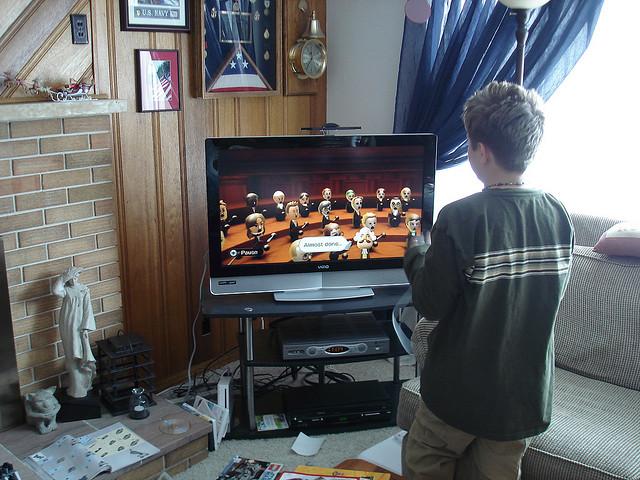Is this a cafe?
Short answer required. No. Is the boy playing with someone?
Give a very brief answer. No. Are there stripes on his shirt?
Write a very short answer. Yes. What does the screen say?
Answer briefly. Almost done. Is there a statue on the floor?
Concise answer only. Yes. How many people are watching?
Answer briefly. 1. 